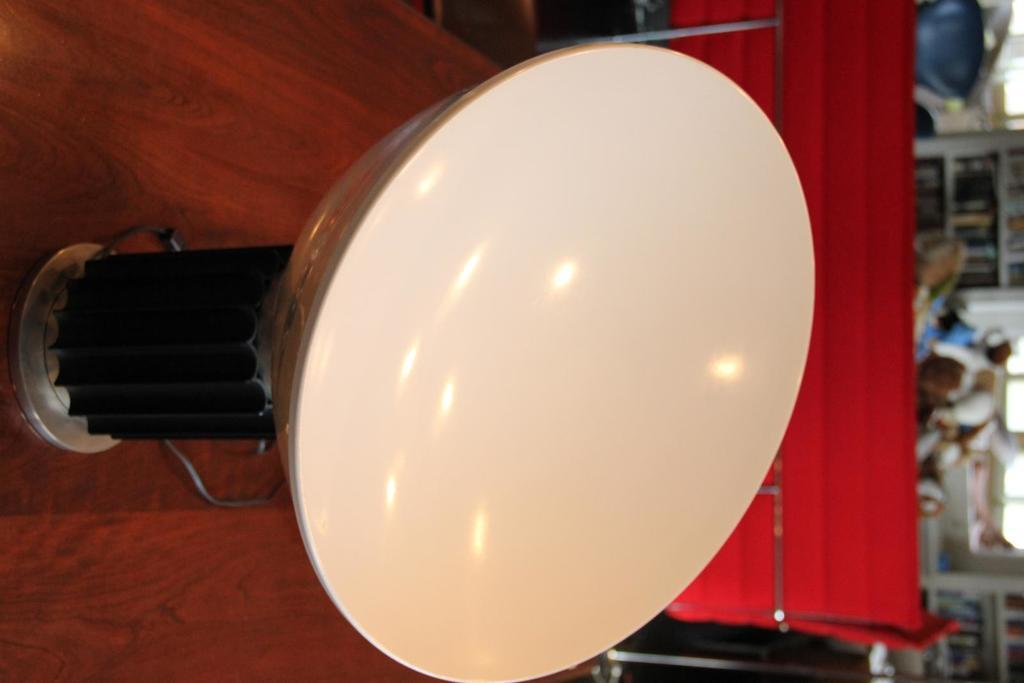What is the main subject of the image? There is an object on a table in the image. Can you describe the object on the table? Unfortunately, the provided facts do not give enough information to describe the object on the table. What can be seen in the background of the image? There are objects visible in the background of the image. What type of industry is depicted in the image? There is no industry depicted in the image; it only shows an object on a table and objects in the background. How many feet are visible in the image? There are no feet visible in the image. 